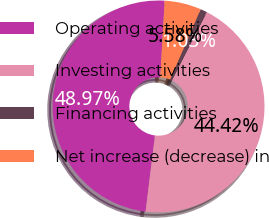Convert chart to OTSL. <chart><loc_0><loc_0><loc_500><loc_500><pie_chart><fcel>Operating activities<fcel>Investing activities<fcel>Financing activities<fcel>Net increase (decrease) in<nl><fcel>48.97%<fcel>44.42%<fcel>1.03%<fcel>5.58%<nl></chart> 